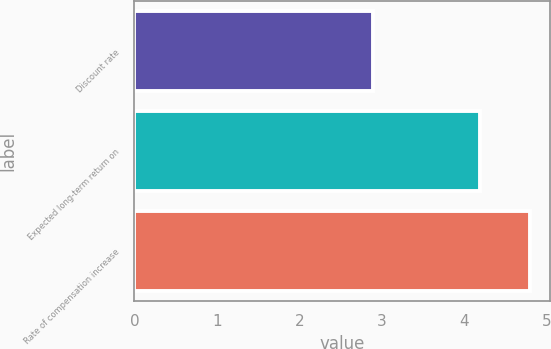<chart> <loc_0><loc_0><loc_500><loc_500><bar_chart><fcel>Discount rate<fcel>Expected long-term return on<fcel>Rate of compensation increase<nl><fcel>2.9<fcel>4.2<fcel>4.8<nl></chart> 